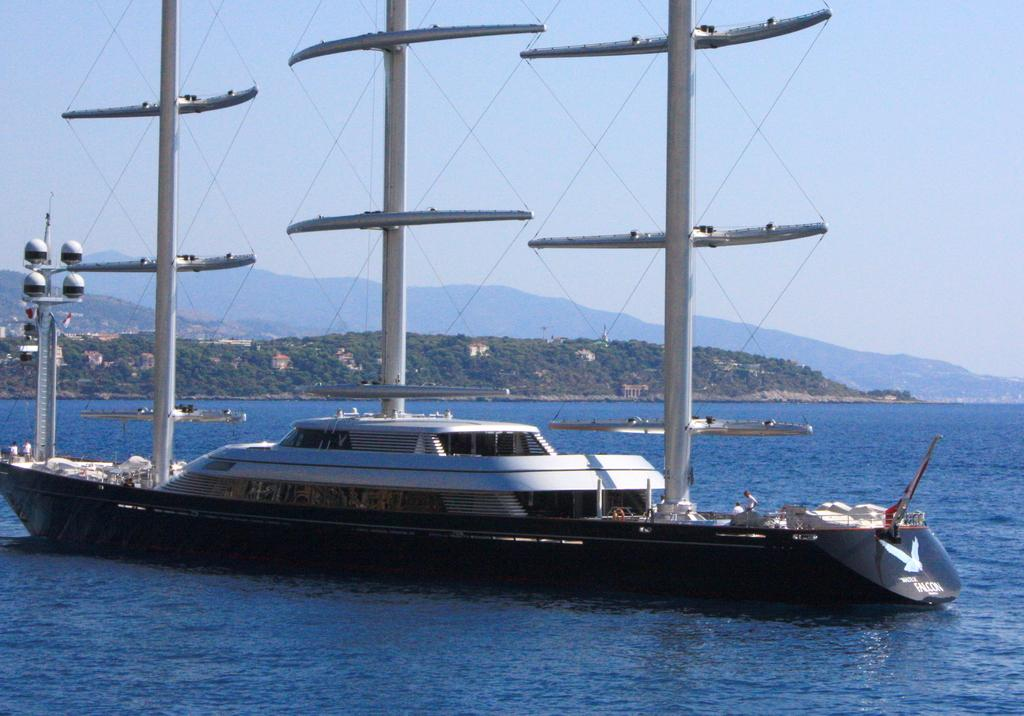What is the main feature of the image? The main feature of the image is water. What else can be seen in the water? There are boats in the water. What other elements are present in the image? There are trees, houses, hills, and the sky visible in the image. Can you tell me how many parcels are floating in the water in the image? There are no parcels present in the image; it features water, boats, trees, houses, hills, and the sky. Is there any oil visible on the surface of the water in the image? There is no oil visible on the surface of the water in the image. 